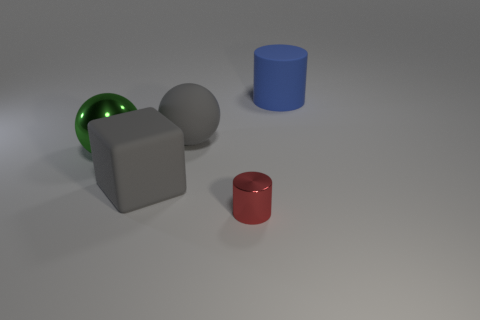Add 3 shiny things. How many objects exist? 8 Subtract all spheres. How many objects are left? 3 Subtract 0 green cylinders. How many objects are left? 5 Subtract all balls. Subtract all metal objects. How many objects are left? 1 Add 5 green spheres. How many green spheres are left? 6 Add 5 tiny blue matte cubes. How many tiny blue matte cubes exist? 5 